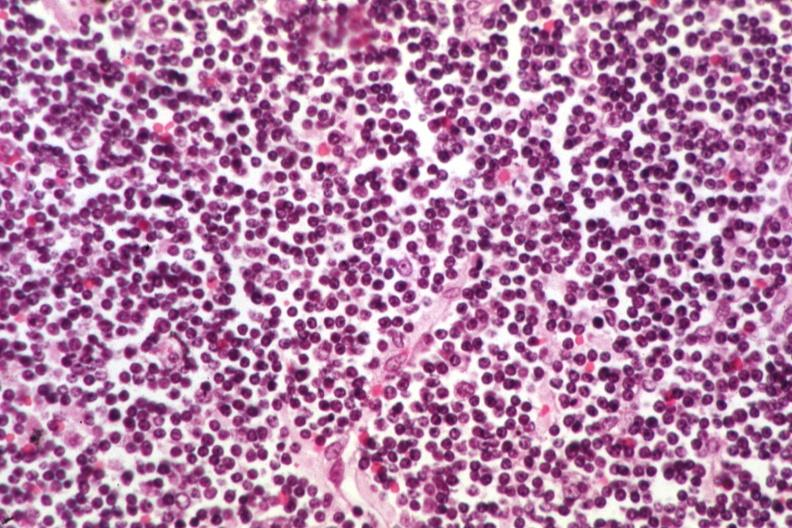s thymoma present?
Answer the question using a single word or phrase. No 